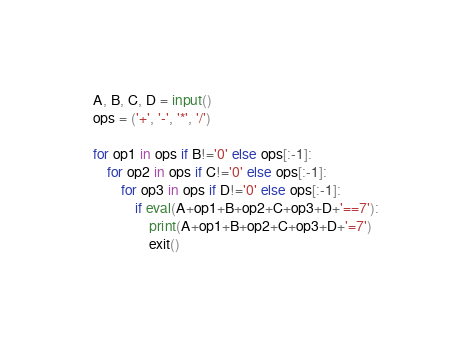Convert code to text. <code><loc_0><loc_0><loc_500><loc_500><_Python_>A, B, C, D = input()
ops = ('+', '-', '*', '/')

for op1 in ops if B!='0' else ops[:-1]:
	for op2 in ops if C!='0' else ops[:-1]:
		for op3 in ops if D!='0' else ops[:-1]:
			if eval(A+op1+B+op2+C+op3+D+'==7'):
				print(A+op1+B+op2+C+op3+D+'=7')
				exit()</code> 